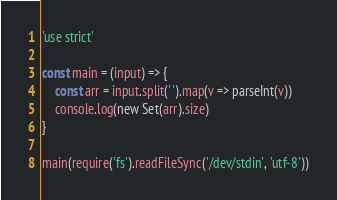<code> <loc_0><loc_0><loc_500><loc_500><_JavaScript_>'use strict'

const main = (input) => {
    const arr = input.split(' ').map(v => parseInt(v))
    console.log(new Set(arr).size)
}

main(require('fs').readFileSync('/dev/stdin', 'utf-8'))</code> 